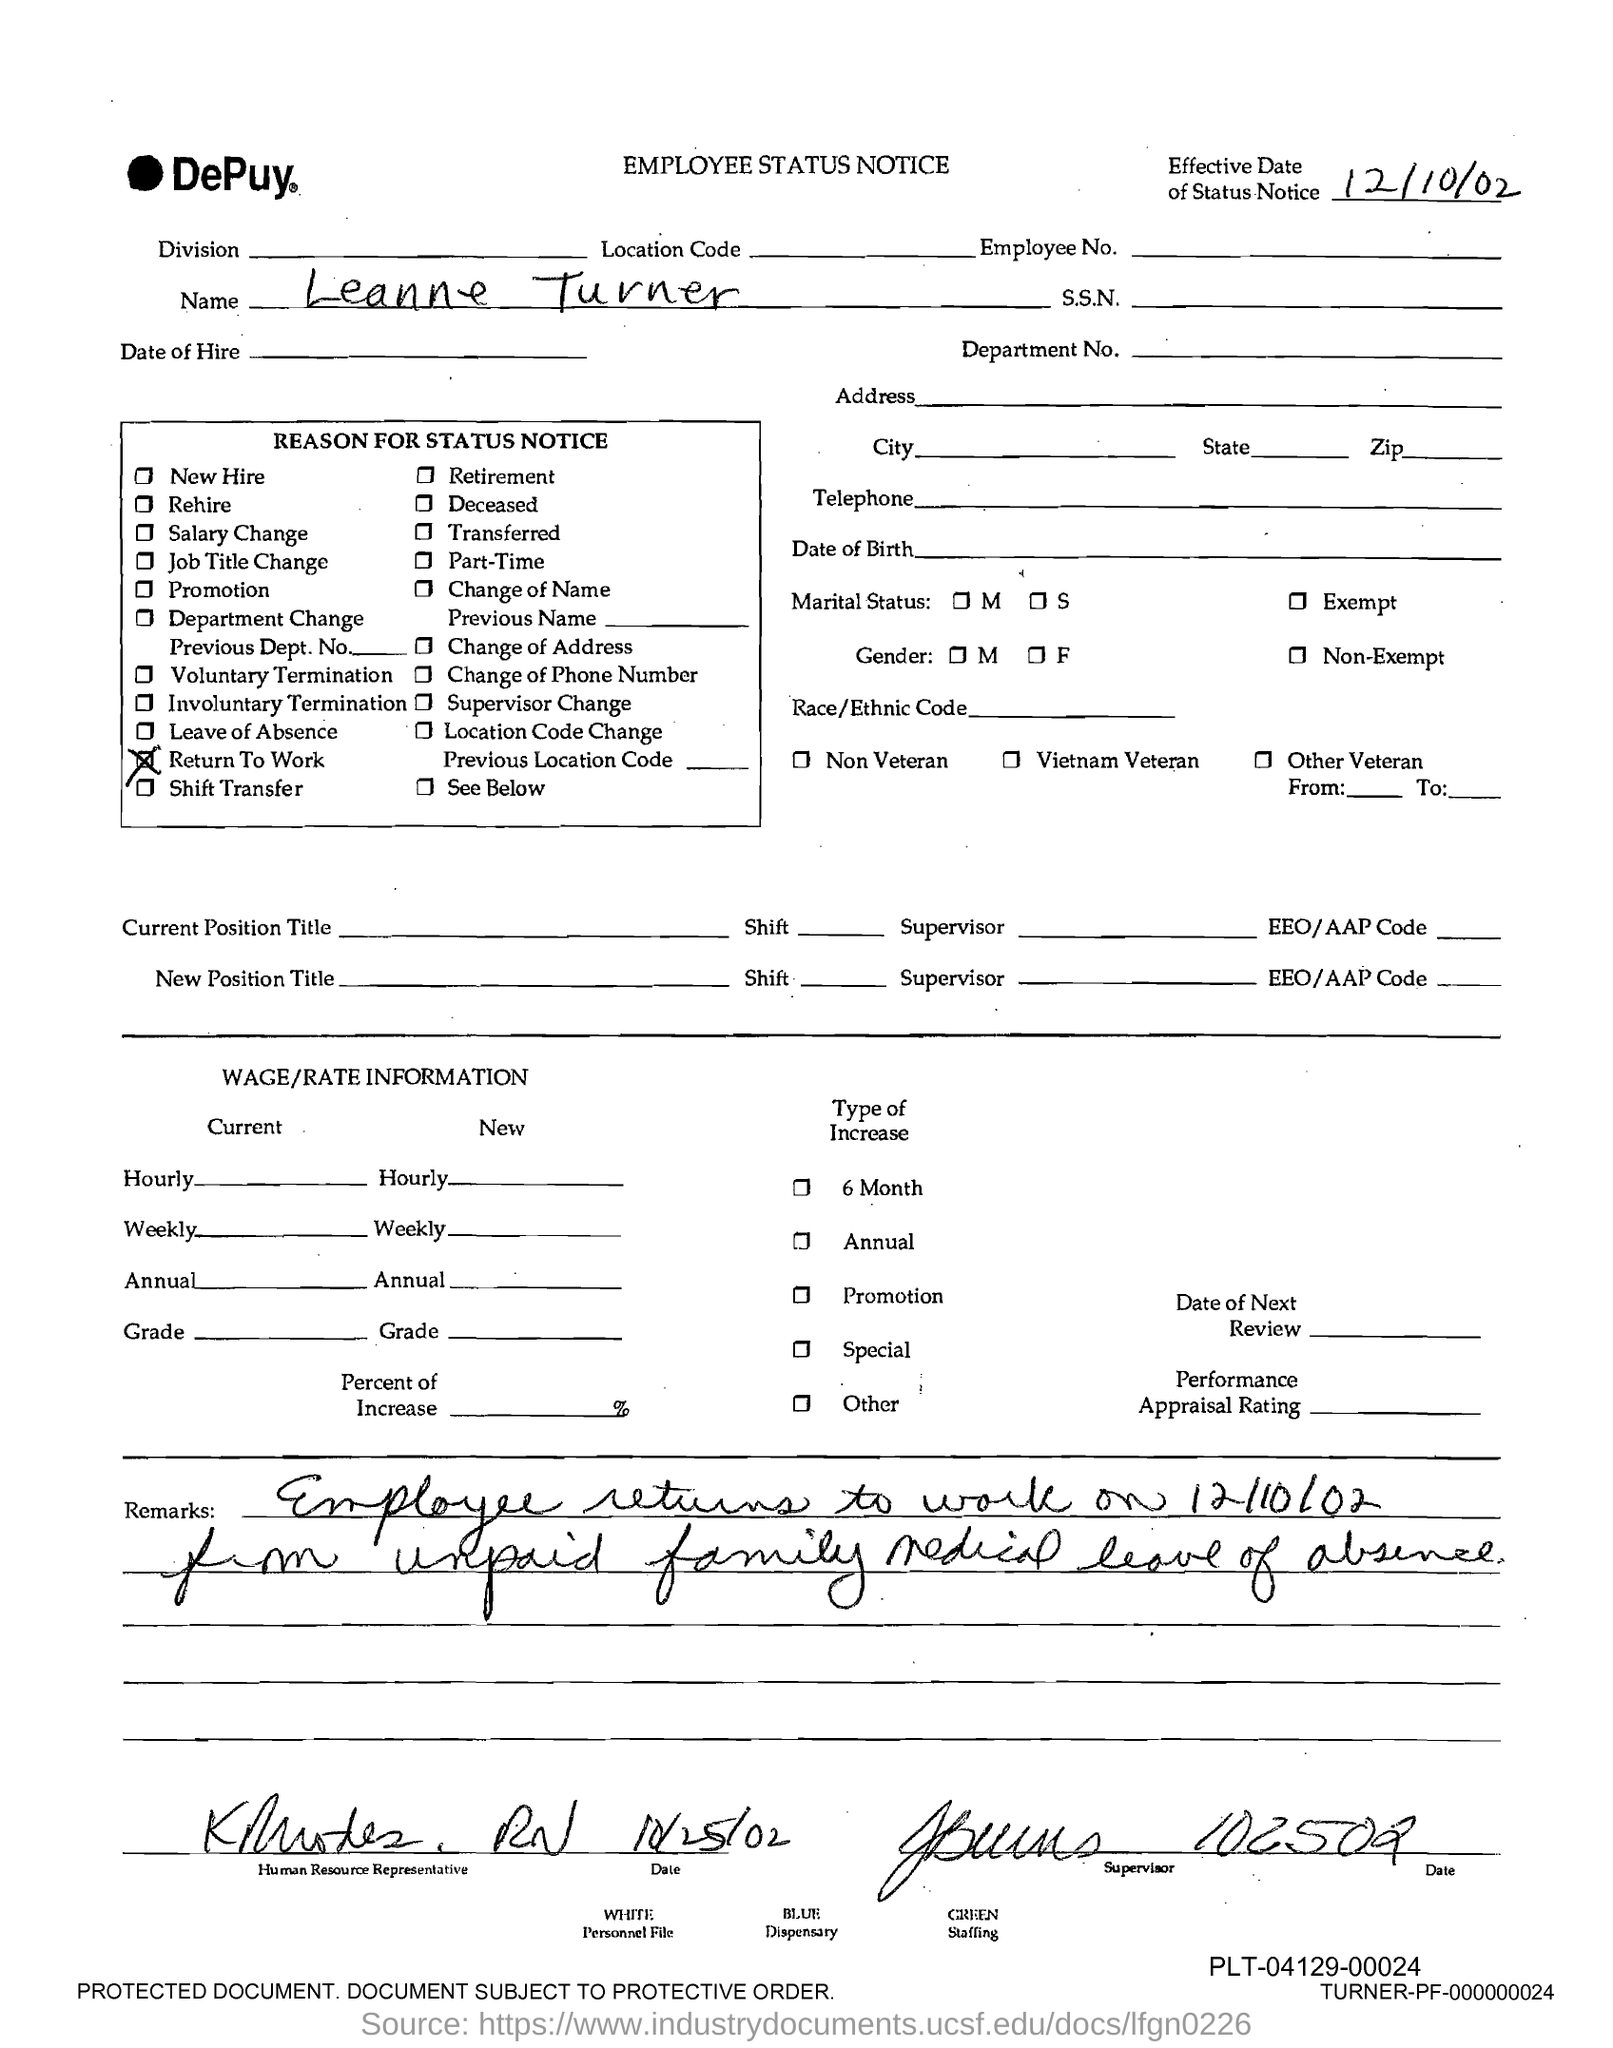What is the name of the person mentioned in the document?
Your answer should be compact. Leanne Turner. 